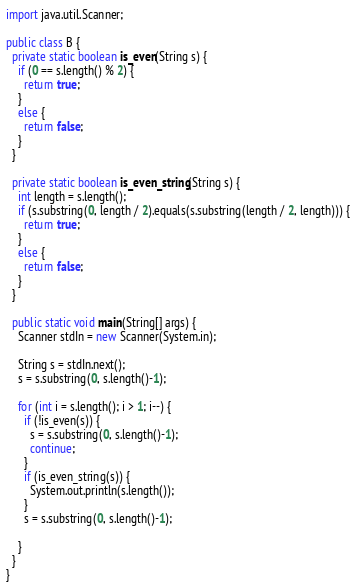<code> <loc_0><loc_0><loc_500><loc_500><_Java_>import java.util.Scanner;

public class B {
  private static boolean is_even(String s) {
    if (0 == s.length() % 2) {
      return true;
    }
    else {
      return false;
    }
  }

  private static boolean is_even_string(String s) {
    int length = s.length();
    if (s.substring(0, length / 2).equals(s.substring(length / 2, length))) {
      return true;
    }
    else {
      return false;
    }
  }

  public static void main(String[] args) {
    Scanner stdIn = new Scanner(System.in);

    String s = stdIn.next();
    s = s.substring(0, s.length()-1);

    for (int i = s.length(); i > 1; i--) {
      if (!is_even(s)) {
        s = s.substring(0, s.length()-1);
        continue;
      }
      if (is_even_string(s)) {
        System.out.println(s.length());
      }
      s = s.substring(0, s.length()-1);

    }
  }
}
</code> 